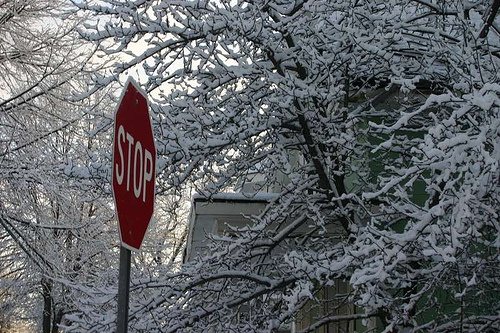Describe the objects in this image and their specific colors. I can see a stop sign in darkgray, maroon, black, and gray tones in this image. 